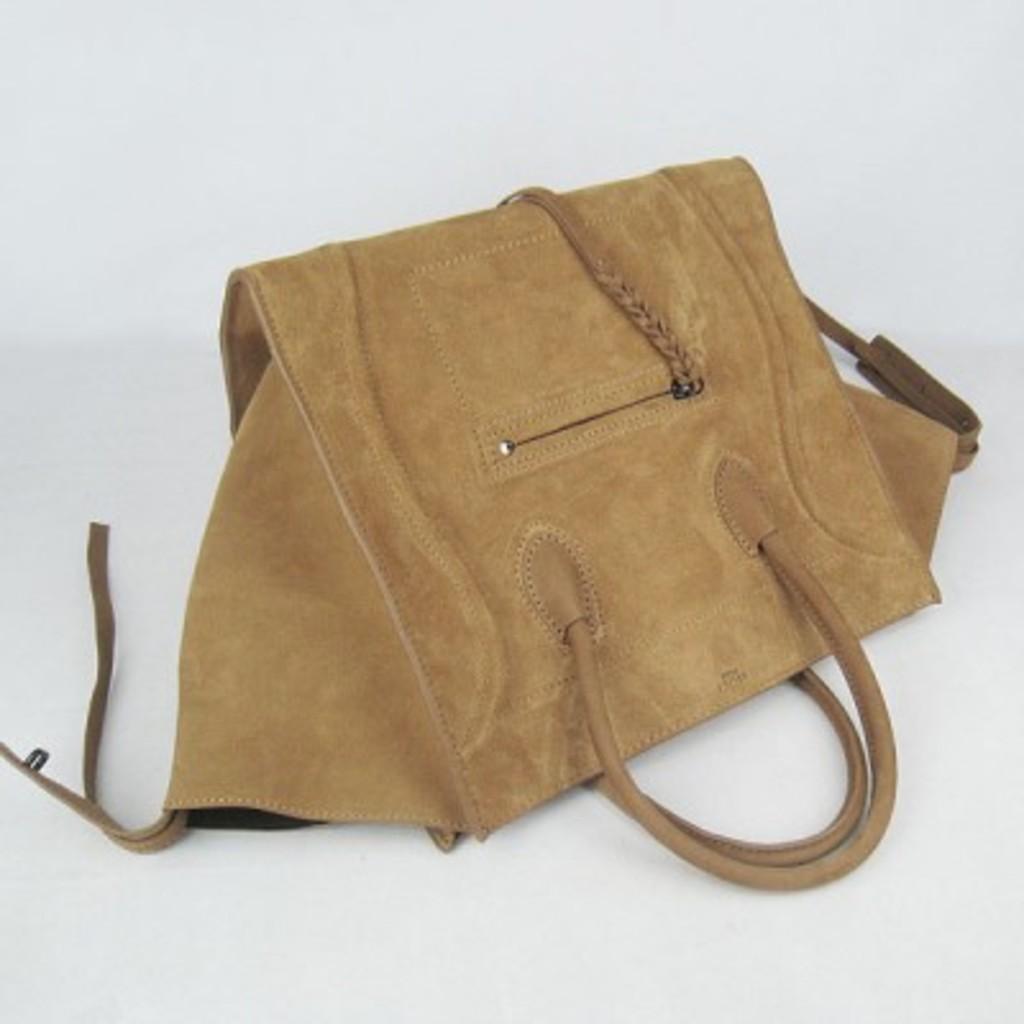How would you summarize this image in a sentence or two? In this image I can see a brown color of handbag. 